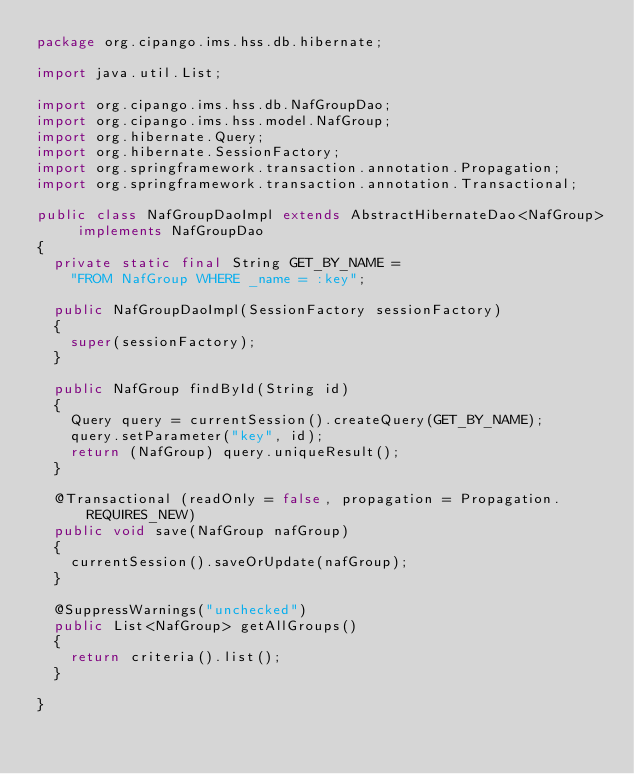Convert code to text. <code><loc_0><loc_0><loc_500><loc_500><_Java_>package org.cipango.ims.hss.db.hibernate;

import java.util.List;

import org.cipango.ims.hss.db.NafGroupDao;
import org.cipango.ims.hss.model.NafGroup;
import org.hibernate.Query;
import org.hibernate.SessionFactory;
import org.springframework.transaction.annotation.Propagation;
import org.springframework.transaction.annotation.Transactional;

public class NafGroupDaoImpl extends AbstractHibernateDao<NafGroup> implements NafGroupDao
{
	private static final String GET_BY_NAME =
		"FROM NafGroup WHERE _name = :key";
	
	public NafGroupDaoImpl(SessionFactory sessionFactory)
	{
		super(sessionFactory);
	}

	public NafGroup findById(String id)
	{
		Query query = currentSession().createQuery(GET_BY_NAME);
		query.setParameter("key", id);
		return (NafGroup) query.uniqueResult();
	}
	
	@Transactional (readOnly = false, propagation = Propagation.REQUIRES_NEW)
	public void save(NafGroup nafGroup)
	{
		currentSession().saveOrUpdate(nafGroup);
	}

	@SuppressWarnings("unchecked")
	public List<NafGroup> getAllGroups()
	{
		return criteria().list();
	}

}
</code> 